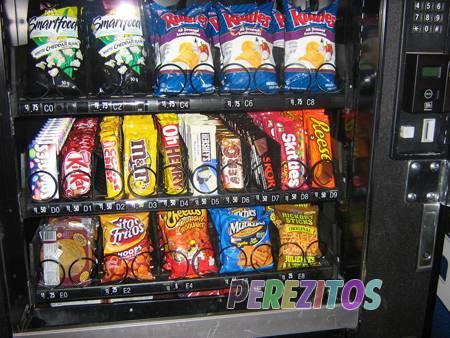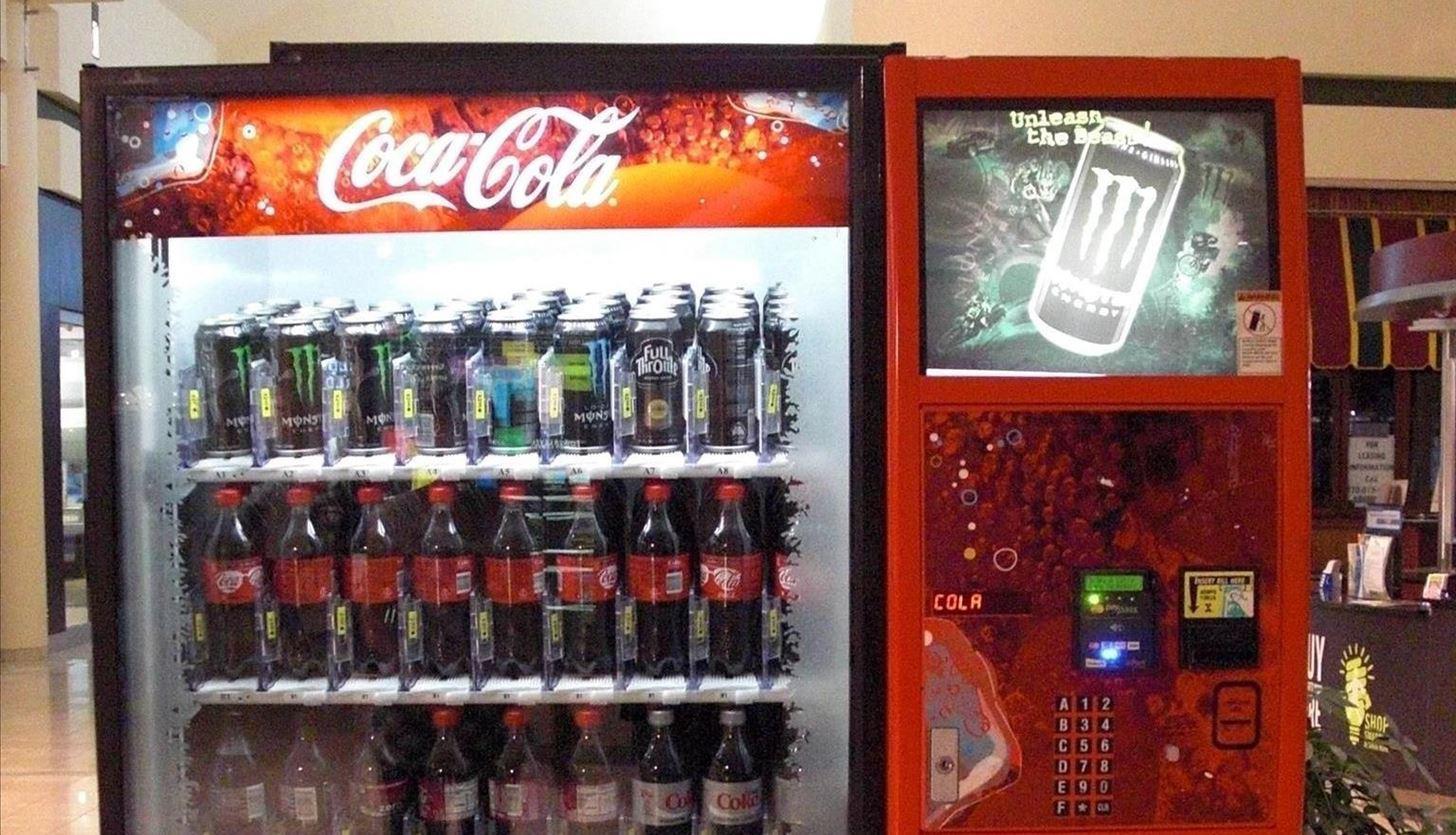The first image is the image on the left, the second image is the image on the right. Evaluate the accuracy of this statement regarding the images: "The machine on the right sells Coca Cola.". Is it true? Answer yes or no. Yes. 